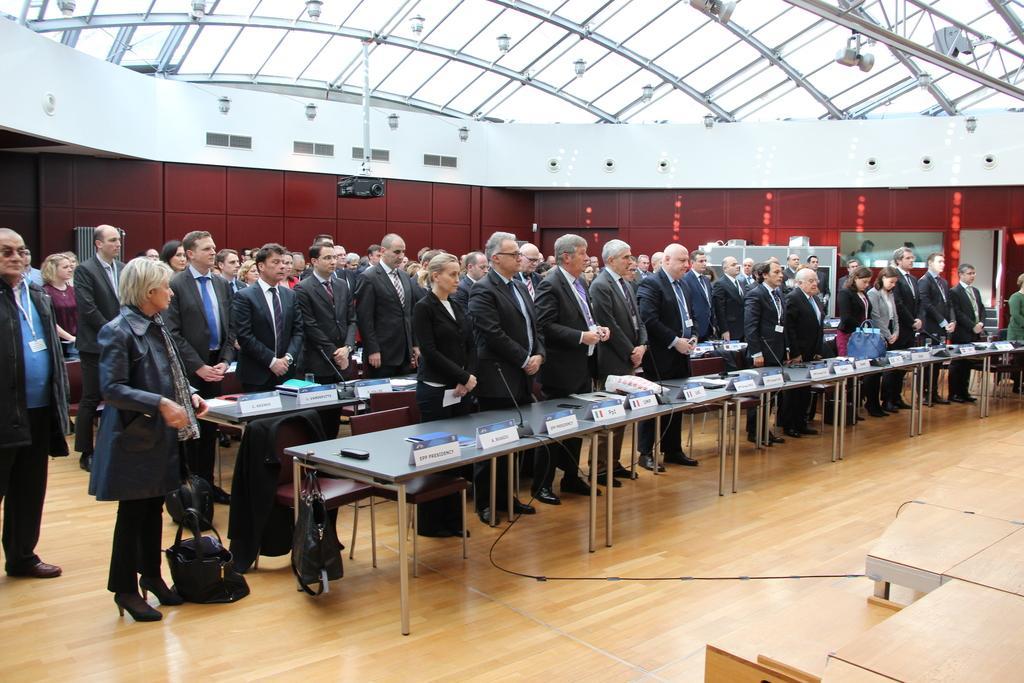In one or two sentences, can you explain what this image depicts? There are people standing and we can see boards, microphones, bag and objects on tables. We can see bags and cable on the floor. In the background we can see wall and projector. At the top we can see lights and glass. 